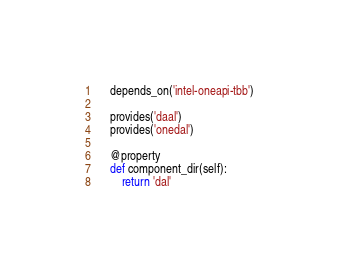Convert code to text. <code><loc_0><loc_0><loc_500><loc_500><_Python_>    depends_on('intel-oneapi-tbb')

    provides('daal')
    provides('onedal')

    @property
    def component_dir(self):
        return 'dal'
</code> 